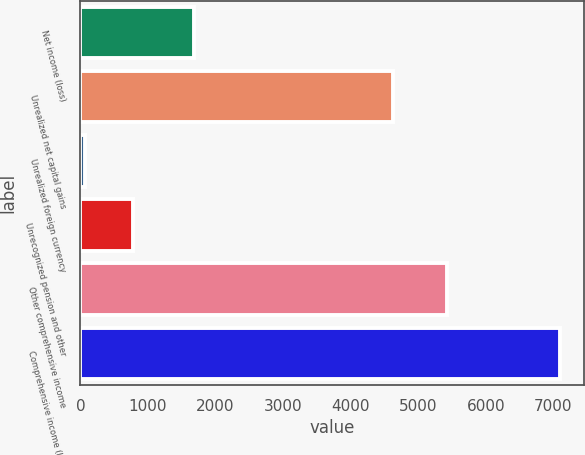Convert chart. <chart><loc_0><loc_0><loc_500><loc_500><bar_chart><fcel>Net income (loss)<fcel>Unrealized net capital gains<fcel>Unrealized foreign currency<fcel>Unrecognized pension and other<fcel>Other comprehensive income<fcel>Comprehensive income (loss)<nl><fcel>1679<fcel>4626<fcel>74<fcel>776.9<fcel>5424<fcel>7103<nl></chart> 